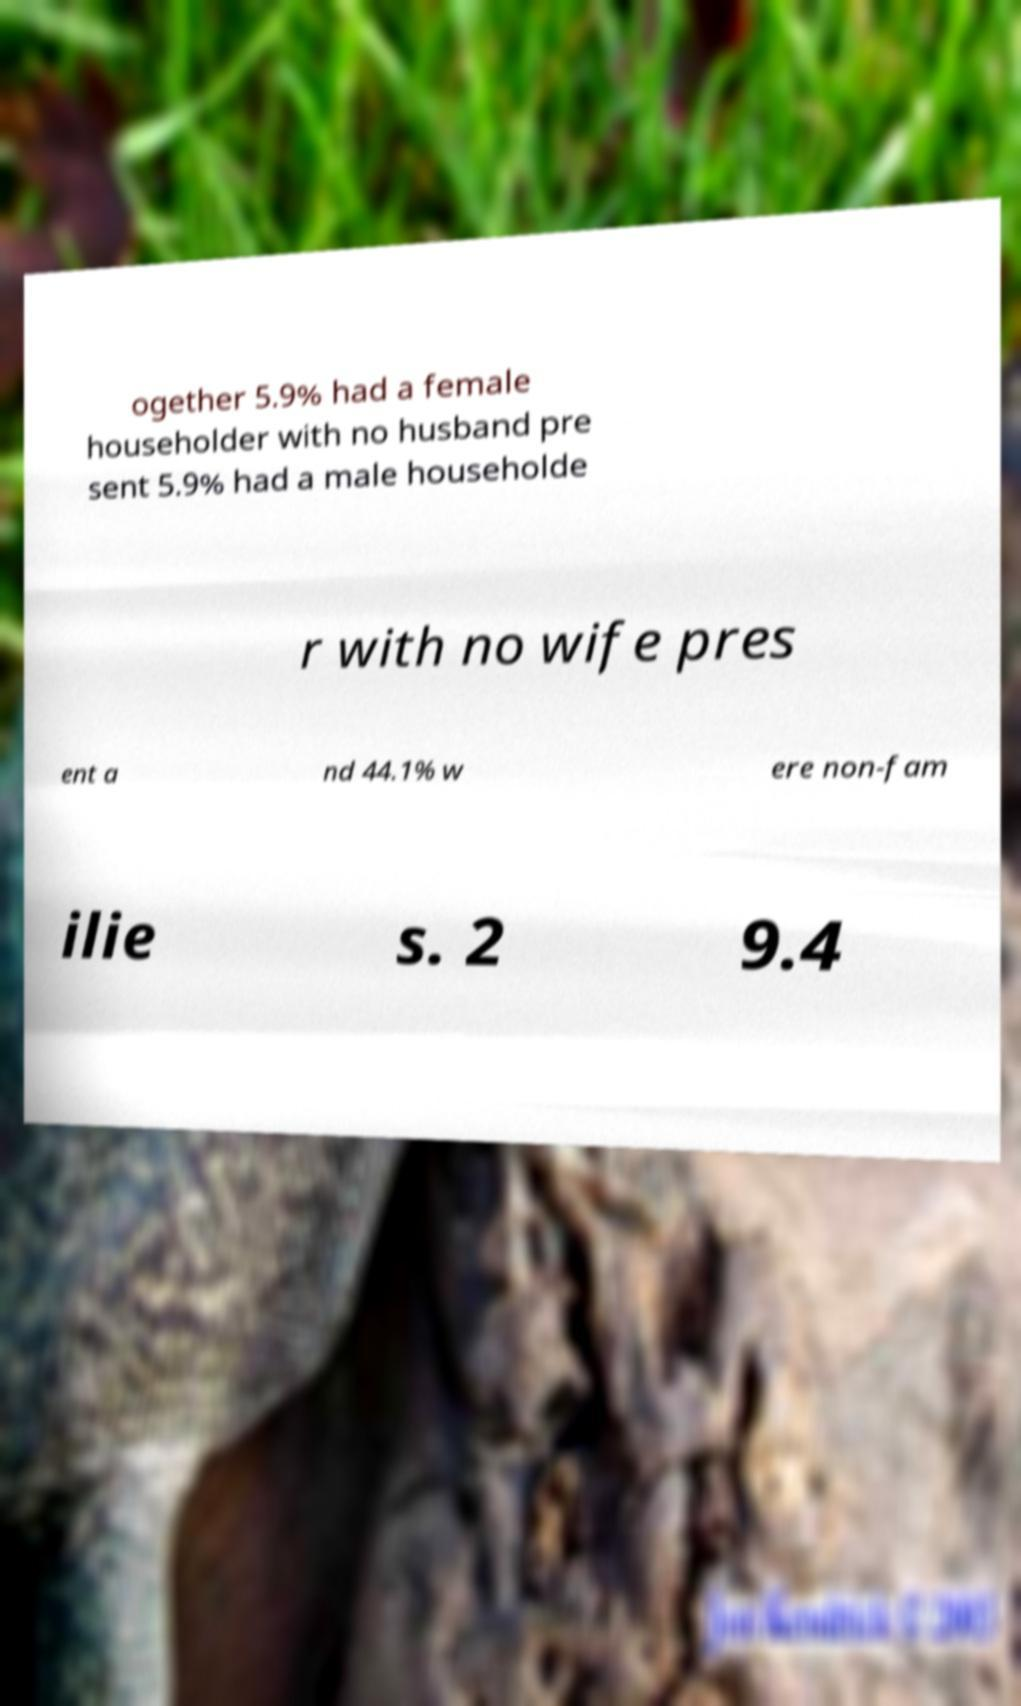I need the written content from this picture converted into text. Can you do that? ogether 5.9% had a female householder with no husband pre sent 5.9% had a male householde r with no wife pres ent a nd 44.1% w ere non-fam ilie s. 2 9.4 